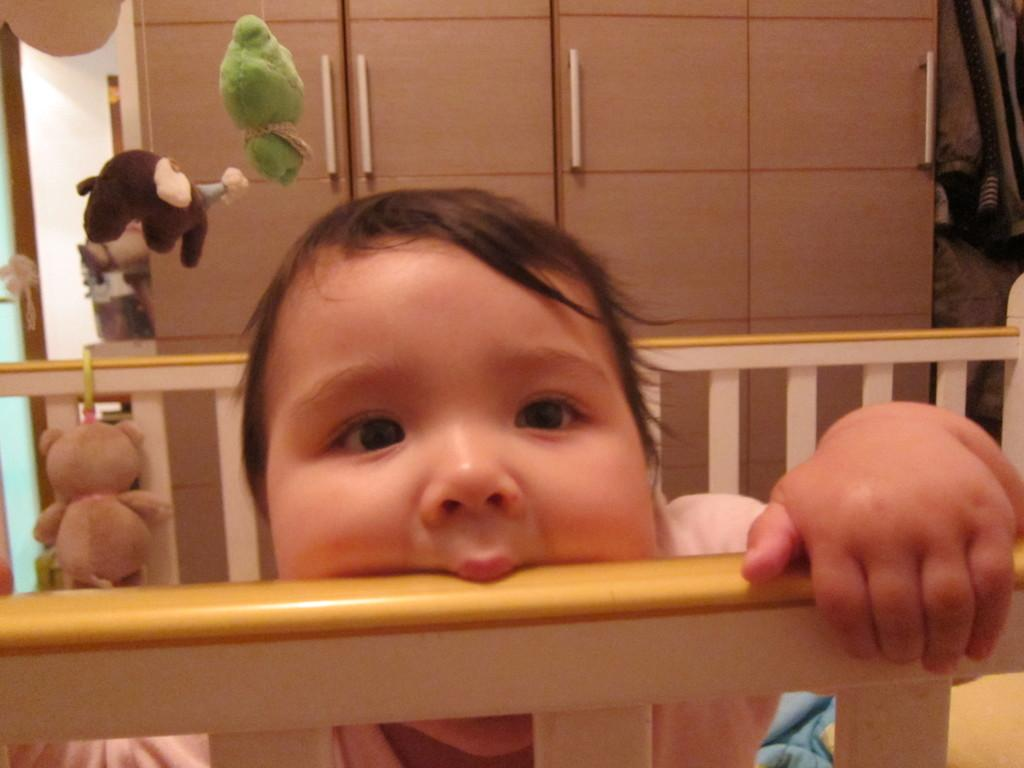What is the main subject in the foreground of the image? There is a kid in the foreground of the image. What is the kid's position or activity in the image? The kid appears to be standing in a cradle. What type of furniture can be seen in the background of the image? There is a wooden cabinet in the background of the image. What other items are present in the background of the image? Clothes and soft toys are visible in the background of the image. How many sisters does the kid have, and where are they located in the image? There is no information about the kid's sisters in the image, so we cannot determine their number or location. What type of animals can be seen at the zoo in the image? There is no zoo present in the image, so we cannot see any animals from a zoo. 